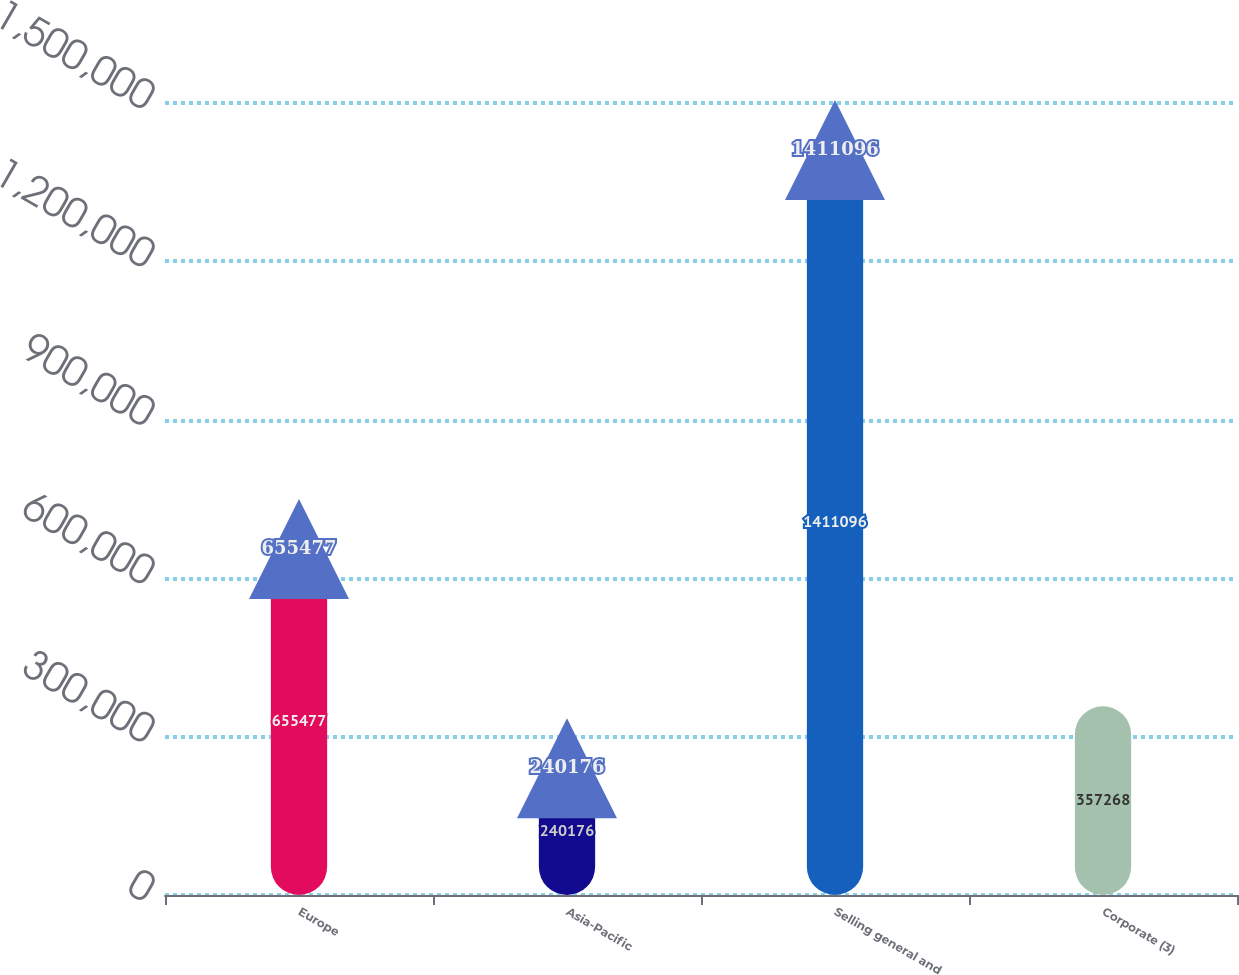Convert chart to OTSL. <chart><loc_0><loc_0><loc_500><loc_500><bar_chart><fcel>Europe<fcel>Asia-Pacific<fcel>Selling general and<fcel>Corporate (3)<nl><fcel>655477<fcel>240176<fcel>1.4111e+06<fcel>357268<nl></chart> 